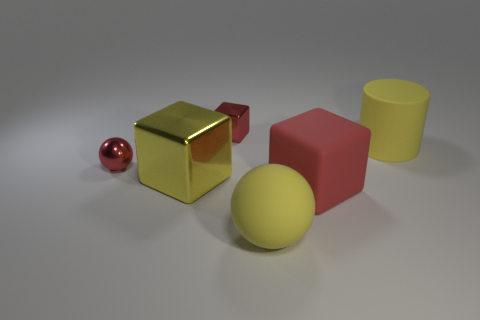What number of objects are either big yellow rubber things that are in front of the large yellow rubber cylinder or small cubes?
Offer a terse response. 2. Is the shape of the red matte object the same as the yellow metallic thing?
Keep it short and to the point. Yes. How many other things are the same size as the red metal ball?
Give a very brief answer. 1. The tiny metallic cube is what color?
Keep it short and to the point. Red. What number of tiny things are yellow matte cylinders or yellow shiny things?
Your answer should be compact. 0. There is a yellow matte thing left of the big yellow rubber cylinder; is its size the same as the red block in front of the large cylinder?
Make the answer very short. Yes. There is a yellow object that is the same shape as the red matte object; what size is it?
Make the answer very short. Large. Are there more tiny red spheres to the right of the large red object than large metal objects that are on the left side of the yellow metallic object?
Ensure brevity in your answer.  No. What is the red thing that is on the right side of the small metal ball and behind the large yellow metallic object made of?
Your answer should be compact. Metal. What is the color of the big rubber thing that is the same shape as the large yellow metallic object?
Ensure brevity in your answer.  Red. 